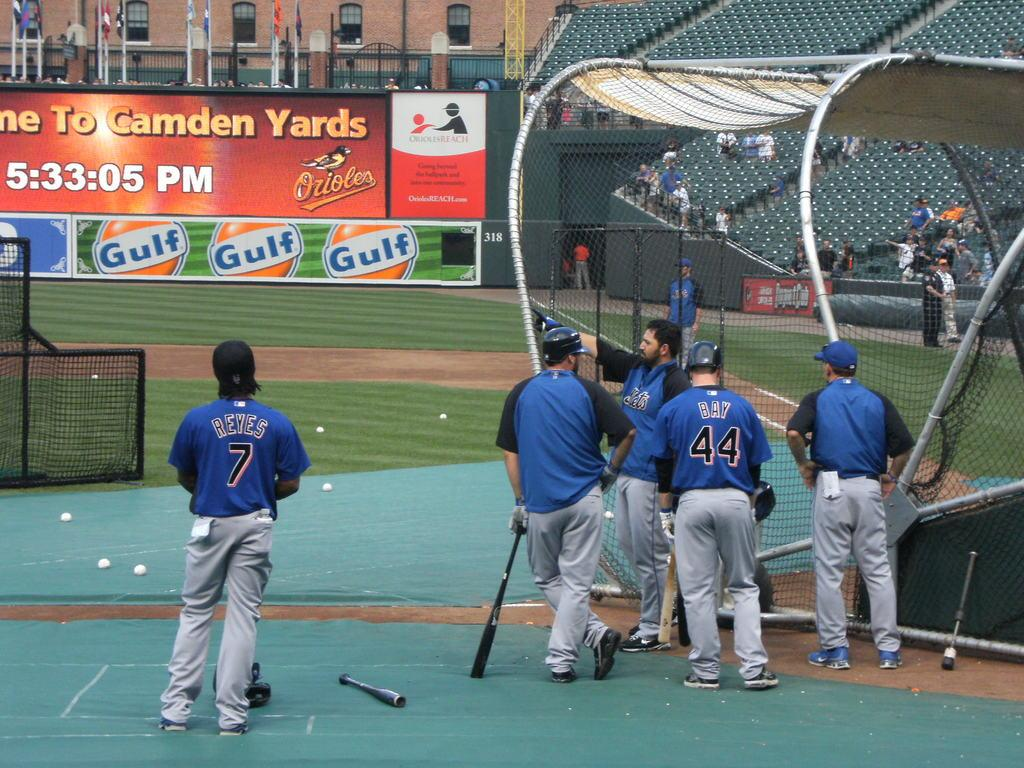<image>
Offer a succinct explanation of the picture presented. A baseball player Reyes wearing the number 7 stands apart from his teammates. 